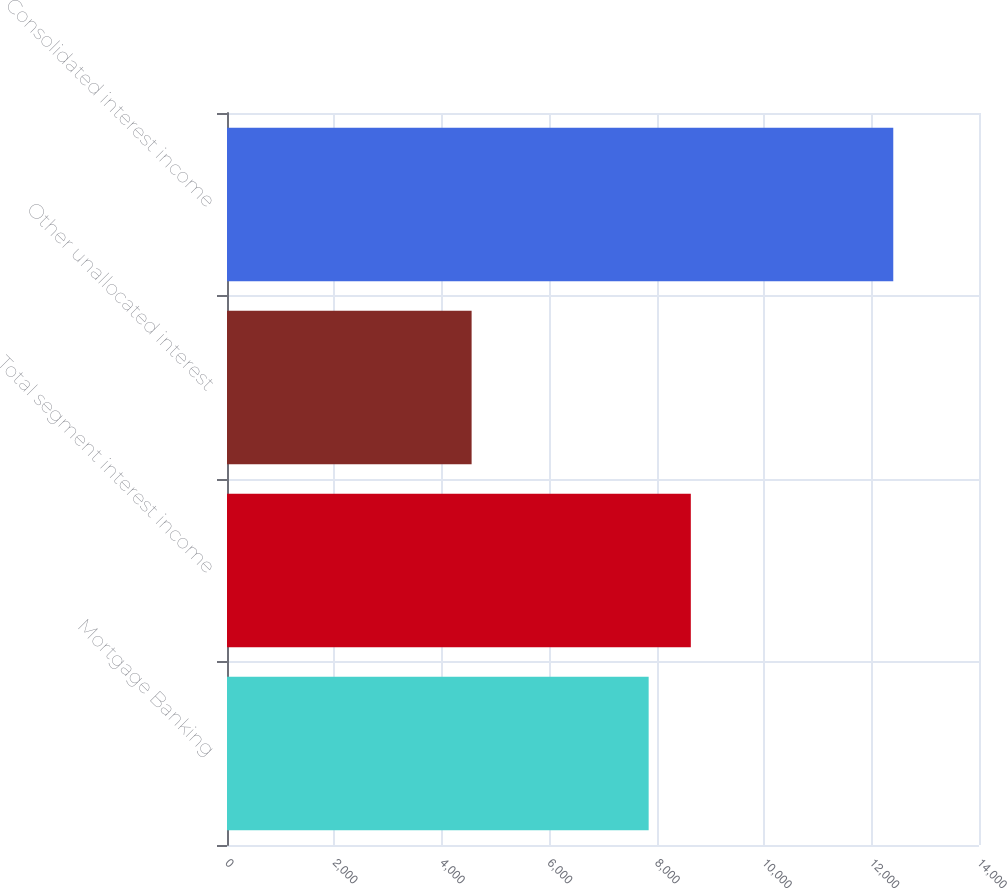Convert chart to OTSL. <chart><loc_0><loc_0><loc_500><loc_500><bar_chart><fcel>Mortgage Banking<fcel>Total segment interest income<fcel>Other unallocated interest<fcel>Consolidated interest income<nl><fcel>7850<fcel>8635<fcel>4554<fcel>12404<nl></chart> 